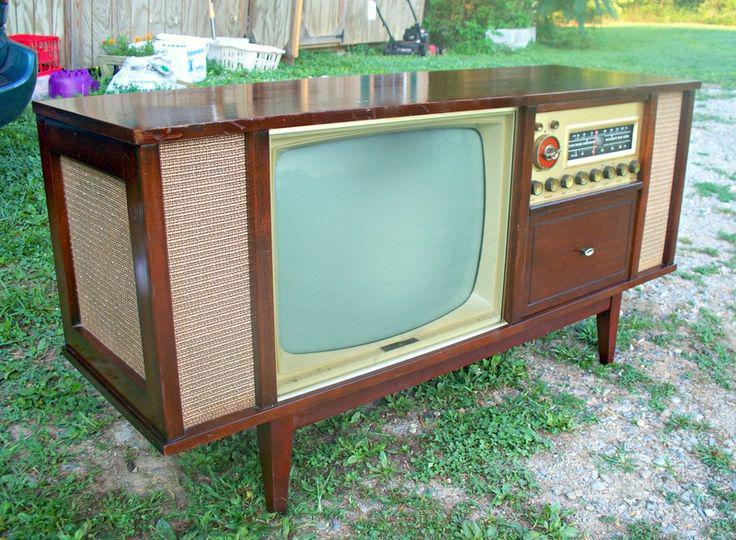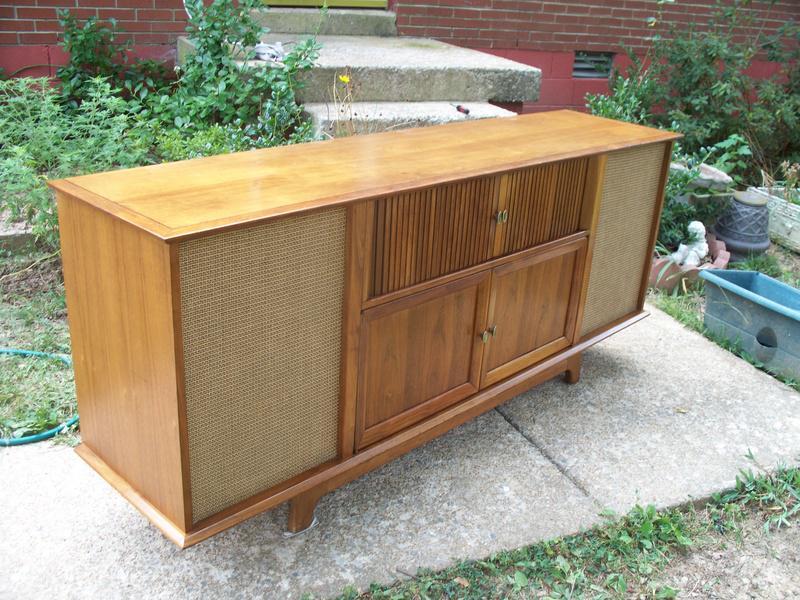The first image is the image on the left, the second image is the image on the right. For the images displayed, is the sentence "Exactly one TV has four legs sitting on a hard, non-grassy surface, and at least one TV has a screen with four rounded corners." factually correct? Answer yes or no. No. The first image is the image on the left, the second image is the image on the right. Assess this claim about the two images: "In one image, a television and a radio unit are housed in a long wooden console cabinet on short legs that has speakers on the front and end.". Correct or not? Answer yes or no. Yes. 